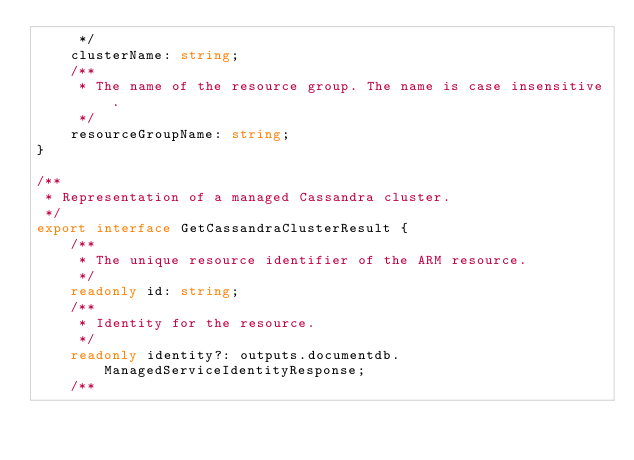Convert code to text. <code><loc_0><loc_0><loc_500><loc_500><_TypeScript_>     */
    clusterName: string;
    /**
     * The name of the resource group. The name is case insensitive.
     */
    resourceGroupName: string;
}

/**
 * Representation of a managed Cassandra cluster.
 */
export interface GetCassandraClusterResult {
    /**
     * The unique resource identifier of the ARM resource.
     */
    readonly id: string;
    /**
     * Identity for the resource.
     */
    readonly identity?: outputs.documentdb.ManagedServiceIdentityResponse;
    /**</code> 